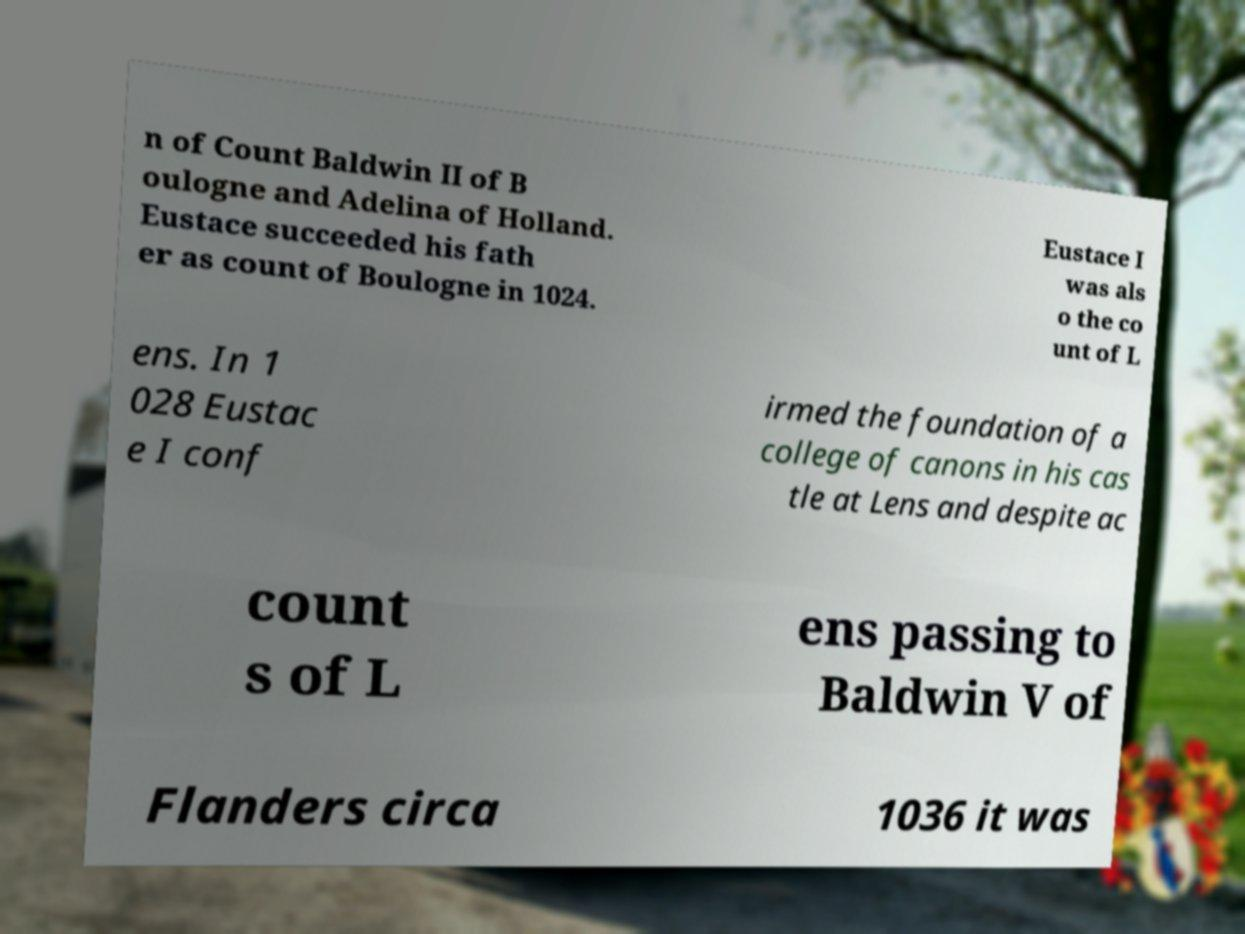There's text embedded in this image that I need extracted. Can you transcribe it verbatim? n of Count Baldwin II of B oulogne and Adelina of Holland. Eustace succeeded his fath er as count of Boulogne in 1024. Eustace I was als o the co unt of L ens. In 1 028 Eustac e I conf irmed the foundation of a college of canons in his cas tle at Lens and despite ac count s of L ens passing to Baldwin V of Flanders circa 1036 it was 